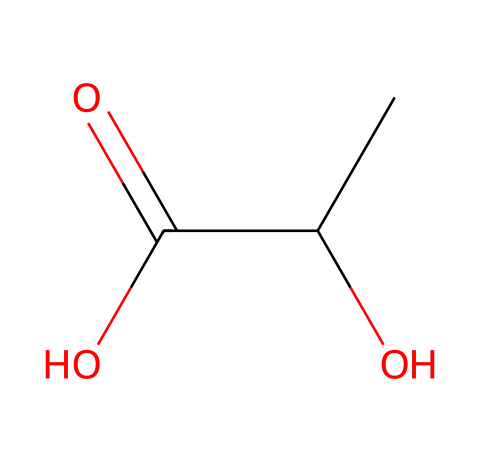What is the main functional group present in this chemical? The chemical structure contains a carboxylic acid group, identifiable by the -COOH functional group in the structure. This group is typical for acids.
Answer: carboxylic acid How many carbon atoms are in the molecule? The structure indicates there are three carbon atoms; this can be counted directly in the SMILES representation.
Answer: three What type of polymerization is used to create polylactic acid? Polylactic acid is formed through condensation polymerization, where lactic acid molecules combine, releasing water.
Answer: condensation What property does the hydroxyl group (-OH) impart to the molecule? The hydroxyl group enhances the molecule's ability to form hydrogen bonds, contributing to properties such as solubility and thermal stability.
Answer: hydrogen bonding What type of biodegradable process can this material undergo? Polylactic acid typically degrades by hydrolysis, a process where the polymer is broken down through reaction with water.
Answer: hydrolysis Which isomer of lactic acid is primarily used to produce PLA? The primary isomer used for PLA production is L-lactic acid, which has distinct stereochemistry affecting the polymer’s properties.
Answer: L-lactic acid 